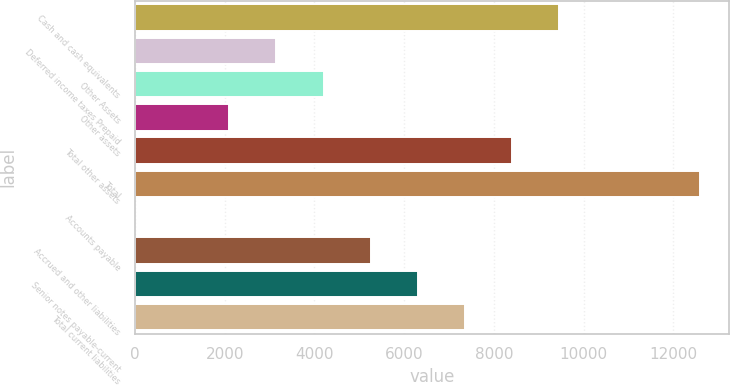<chart> <loc_0><loc_0><loc_500><loc_500><bar_chart><fcel>Cash and cash equivalents<fcel>Deferred income taxes Prepaid<fcel>Other Assets<fcel>Other assets<fcel>Total other assets<fcel>Total<fcel>Accounts payable<fcel>Accrued and other liabilities<fcel>Senior notes payable-current<fcel>Total current liabilities<nl><fcel>9453.2<fcel>3154.4<fcel>4204.2<fcel>2104.6<fcel>8403.4<fcel>12602.6<fcel>5<fcel>5254<fcel>6303.8<fcel>7353.6<nl></chart> 